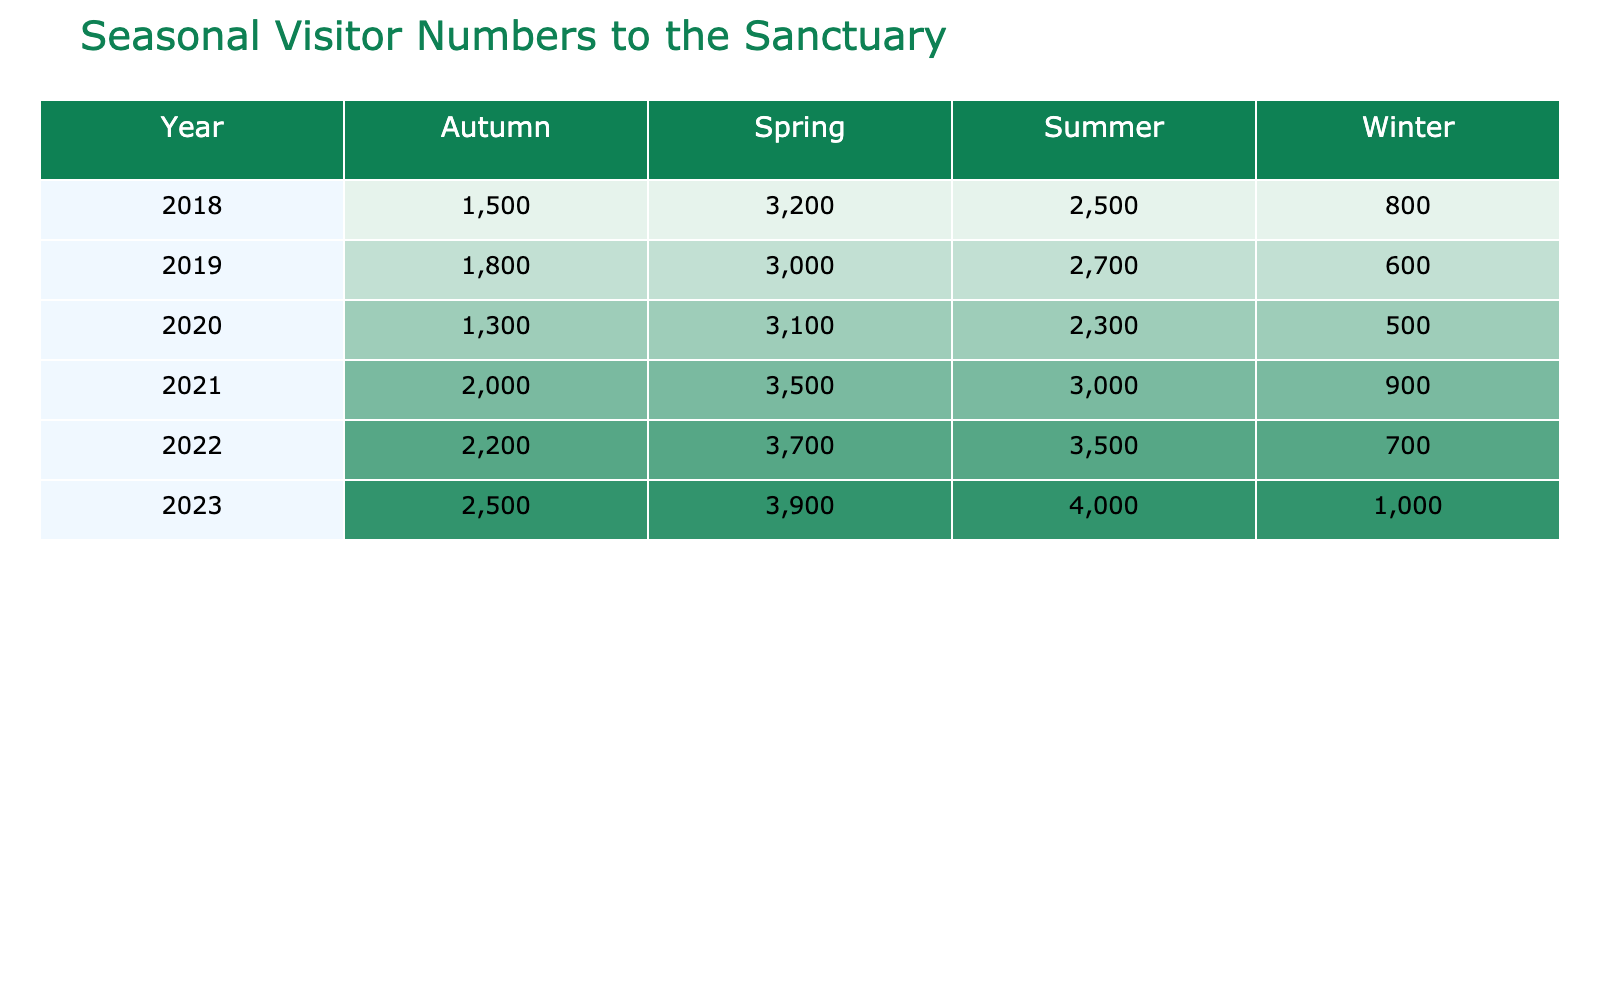What was the highest visitor count in 2023? The table shows that in the summer of 2023, the visitor count was 4000, which is the highest count recorded for that year across all seasons.
Answer: 4000 In which season do visitors tend to come the most on average over the years? To find the average count for each season, we sum the visitor counts for each season and divide by the number of years. For summer: (2500 + 2700 + 2300 + 3000 + 3500 + 4000) / 6 = 3000. For autumn: (1500 + 1800 + 1300 + 2000 + 2200 + 2500) / 6 = 1867. For winter: (800 + 600 + 500 + 900 + 700 + 1000) / 6 = 667. For spring: (3200 + 3000 + 3100 + 3500 + 3700 + 3900) / 6 = 3450. Spring has the highest average visitor count.
Answer: Spring Was there a decline in visitor numbers from 2019 to 2020 in autumn? In autumn 2019, the visitor count was 1800, and in autumn 2020, it dropped to 1300. This shows a decline.
Answer: Yes How many visitors came to the sanctuary in 2022 compared to 2018? For 2022, the total visitor count is: 3500 (Summer) + 2200 (Autumn) + 700 (Winter) + 3700 (Spring) = 11100. For 2018, it is: 2500 (Summer) + 1500 (Autumn) + 800 (Winter) + 3200 (Spring) = 8000. The difference is 11100 - 8000 = 3100 more visitors in 2022 compared to 2018.
Answer: 3100 Which year had the lowest winter visitor count, and what was that count? In the table, the lowest winter visitor count is found in 2020, with only 500 visitors recorded in winter.
Answer: 500 What is the total visitor count for autumn across all years? To calculate the total for autumn, we add the counts: 1500 (2018) + 1800 (2019) + 1300 (2020) + 2000 (2021) + 2200 (2022) + 2500 (2023) = 11300.
Answer: 11300 Which season experienced the greatest growth in visitors from 2018 to 2023? To determine the growth, we compare each season's visitor count in 2018 to 2023: Summer: 2500 to 4000 (+1500), Autumn: 1500 to 2500 (+1000), Winter: 800 to 1000 (+200), Spring: 3200 to 3900 (+700). Summer experienced the greatest growth of 1500 visitors.
Answer: Summer Is the total visitor count in spring 2021 greater than that in summer 2019? Spring 2021 had a visitor count of 3500, and summer 2019 had 2700. Since 3500 is greater than 2700, it means the spring visitor count is greater.
Answer: Yes 